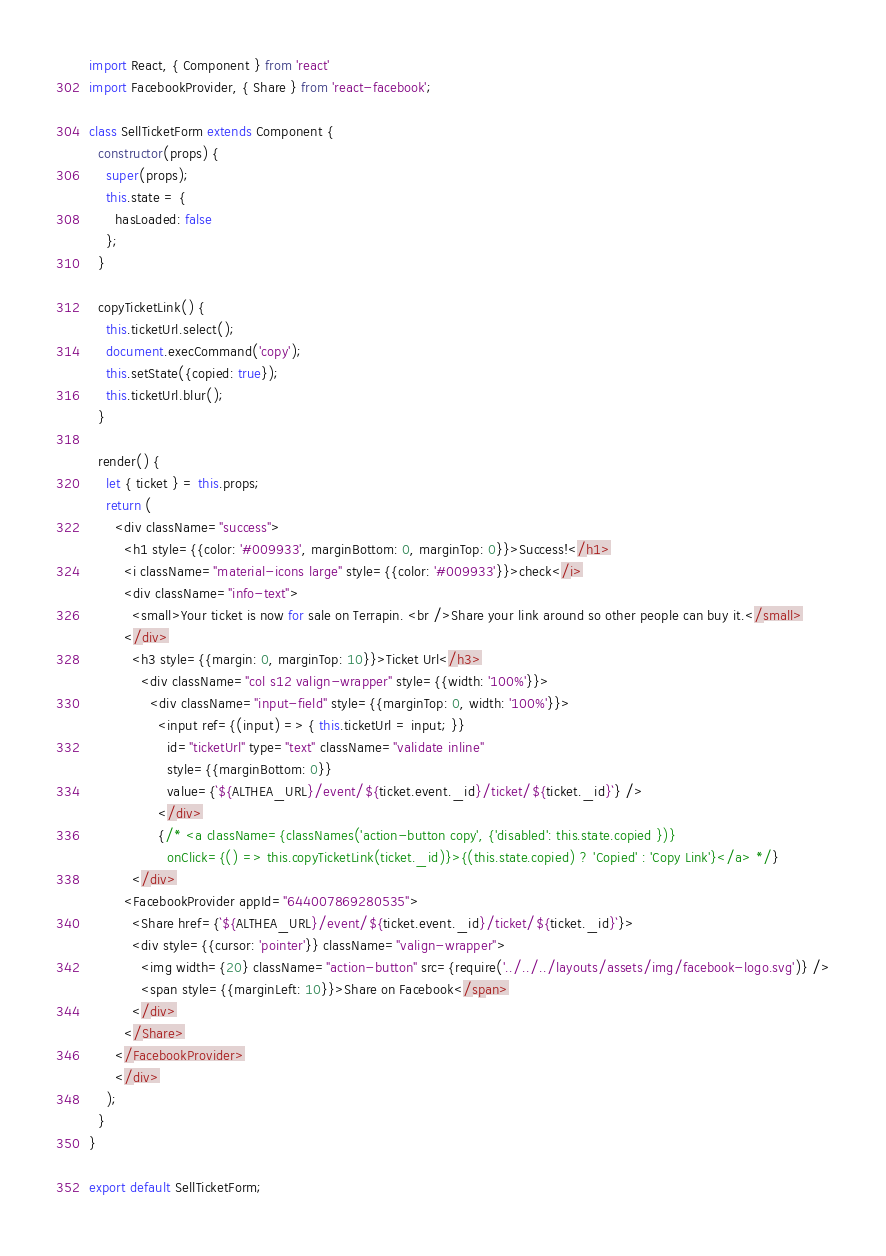<code> <loc_0><loc_0><loc_500><loc_500><_JavaScript_>import React, { Component } from 'react'
import FacebookProvider, { Share } from 'react-facebook';

class SellTicketForm extends Component {
  constructor(props) {
    super(props);
    this.state = {
      hasLoaded: false
    };
  }

  copyTicketLink() {
    this.ticketUrl.select();
    document.execCommand('copy');
    this.setState({copied: true});
    this.ticketUrl.blur();
  }

  render() {
    let { ticket } = this.props;
    return (
      <div className="success">
        <h1 style={{color: '#009933', marginBottom: 0, marginTop: 0}}>Success!</h1>
        <i className="material-icons large" style={{color: '#009933'}}>check</i>
        <div className="info-text">
          <small>Your ticket is now for sale on Terrapin. <br />Share your link around so other people can buy it.</small>
        </div>
          <h3 style={{margin: 0, marginTop: 10}}>Ticket Url</h3>
            <div className="col s12 valign-wrapper" style={{width: '100%'}}>
              <div className="input-field" style={{marginTop: 0, width: '100%'}}>
                <input ref={(input) => { this.ticketUrl = input; }}
                  id="ticketUrl" type="text" className="validate inline"
                  style={{marginBottom: 0}}
                  value={`${ALTHEA_URL}/event/${ticket.event._id}/ticket/${ticket._id}`} />
                </div>
                {/* <a className={classNames('action-button copy', {'disabled': this.state.copied })}
                  onClick={() => this.copyTicketLink(ticket._id)}>{(this.state.copied) ? 'Copied' : 'Copy Link'}</a> */}
          </div>
        <FacebookProvider appId="644007869280535">
          <Share href={`${ALTHEA_URL}/event/${ticket.event._id}/ticket/${ticket._id}`}>
          <div style={{cursor: 'pointer'}} className="valign-wrapper">
            <img width={20} className="action-button" src={require('../../../layouts/assets/img/facebook-logo.svg')} />
            <span style={{marginLeft: 10}}>Share on Facebook</span>
          </div>
        </Share>
      </FacebookProvider>
      </div>
    );
  }
}

export default SellTicketForm;
</code> 